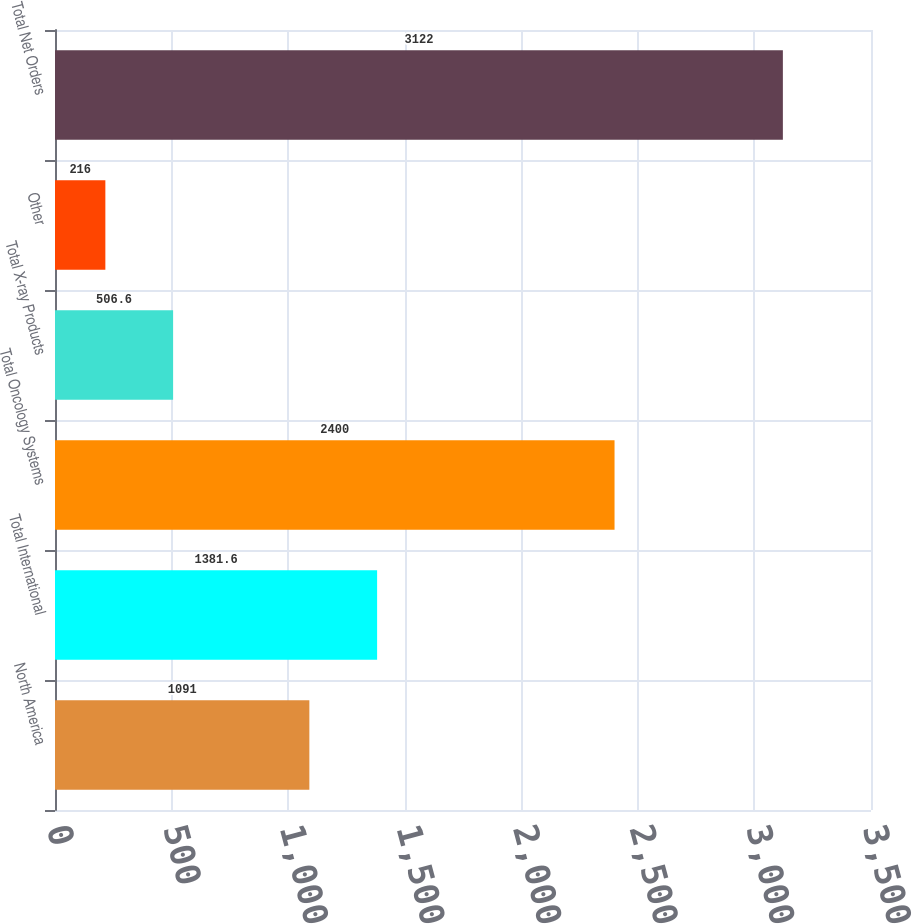Convert chart to OTSL. <chart><loc_0><loc_0><loc_500><loc_500><bar_chart><fcel>North America<fcel>Total International<fcel>Total Oncology Systems<fcel>Total X-ray Products<fcel>Other<fcel>Total Net Orders<nl><fcel>1091<fcel>1381.6<fcel>2400<fcel>506.6<fcel>216<fcel>3122<nl></chart> 